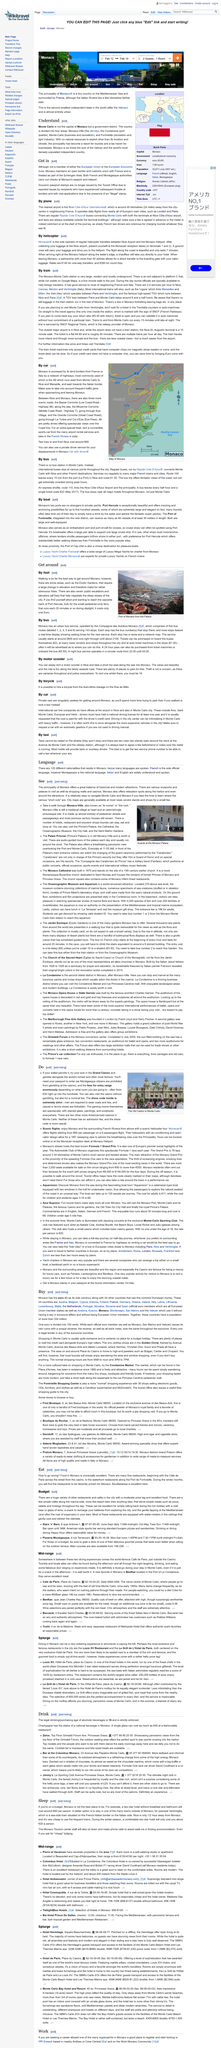Mention a couple of crucial points in this snapshot. The photograph shows the Port of Monaco, which is located in the area depicted. The cost of getting on the ferry is one Euro. Yes, it is possible to navigate the area on foot. 